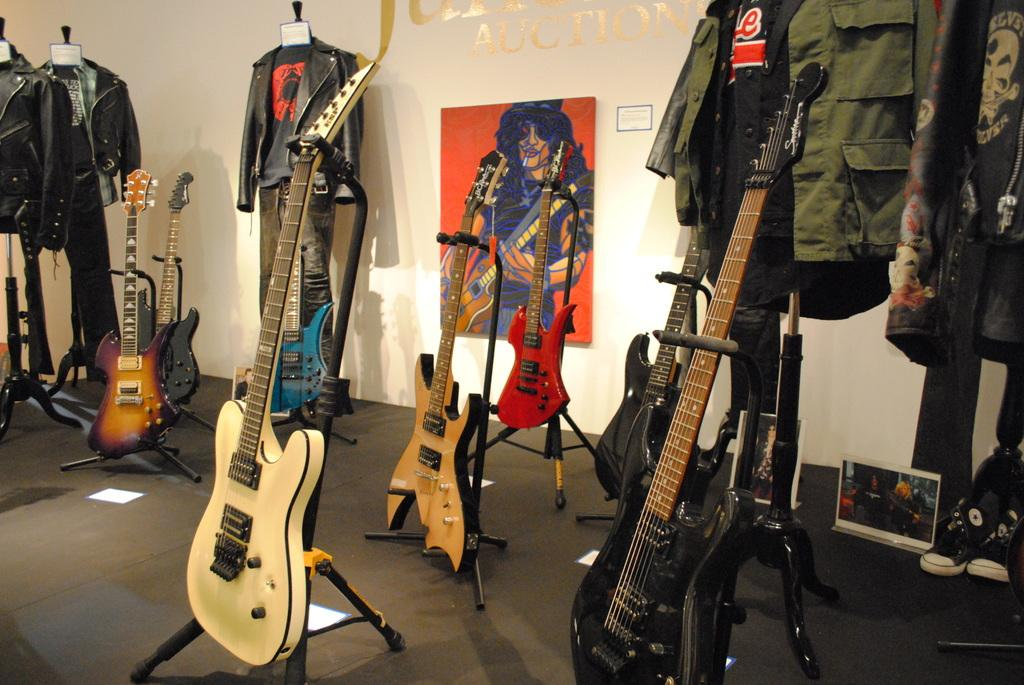What musical instruments are placed on stands in the image? There are guitars placed on stands in the image. What type of clothing items are on hangers in the image? There are jackets on hangers in the image. What decorations are on the wall in the image? There are posters on the wall in the image. Where is the shoe located in the image? The shoe is in the right corner of the image. What is the tendency of the guitars to play themselves in the image? The guitars do not play themselves in the image; they are stationary on stands. Can you see the grandfather playing the guitar in the image? There is no grandfather present in the image. 